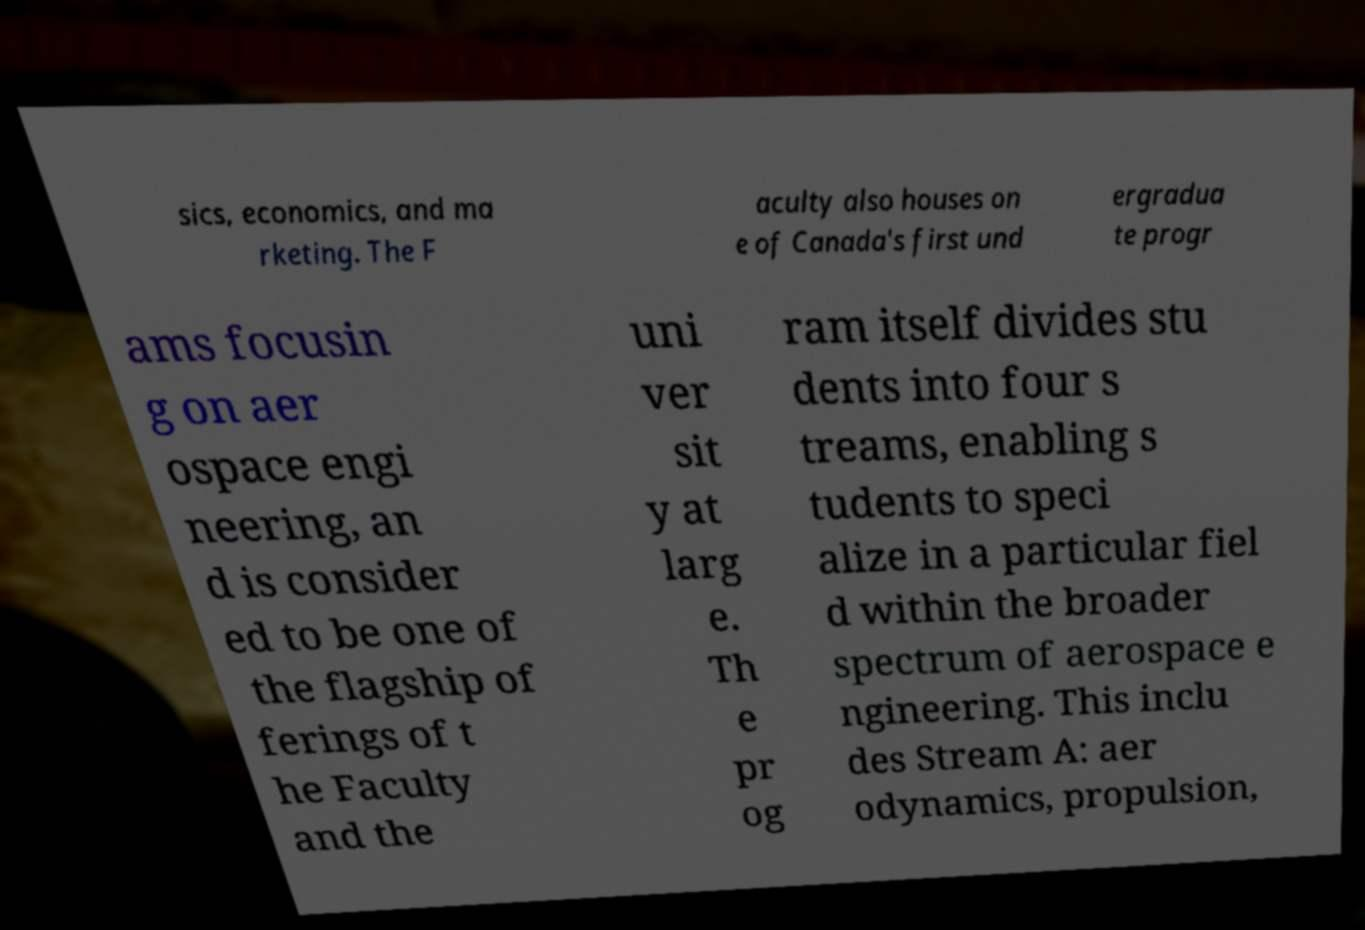For documentation purposes, I need the text within this image transcribed. Could you provide that? sics, economics, and ma rketing. The F aculty also houses on e of Canada's first und ergradua te progr ams focusin g on aer ospace engi neering, an d is consider ed to be one of the flagship of ferings of t he Faculty and the uni ver sit y at larg e. Th e pr og ram itself divides stu dents into four s treams, enabling s tudents to speci alize in a particular fiel d within the broader spectrum of aerospace e ngineering. This inclu des Stream A: aer odynamics, propulsion, 